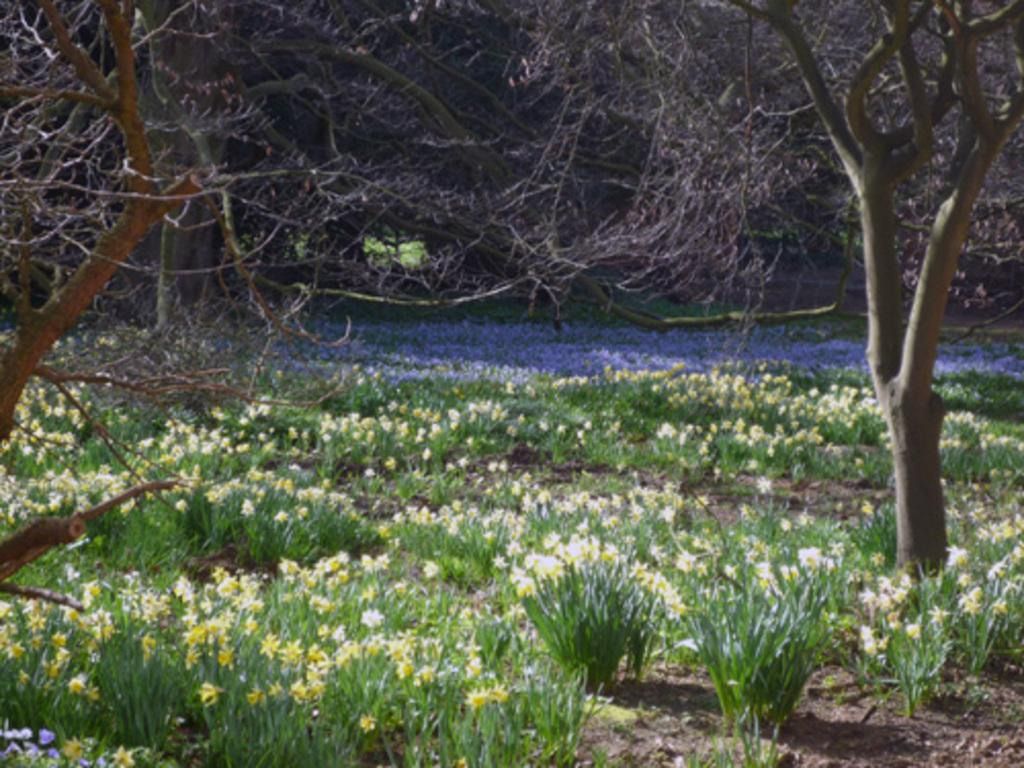What type of plants can be seen in the image? There are plants with flowers in the image. What else can be seen in the image besides the plants? There are trees with branches in the image. How many cars are parked in the crowd in the image? There is no crowd or cars present in the image; it features plants with flowers and trees with branches. What type of metal can be seen on the trees in the image? There is no metal, including zinc, present on the trees in the image. 